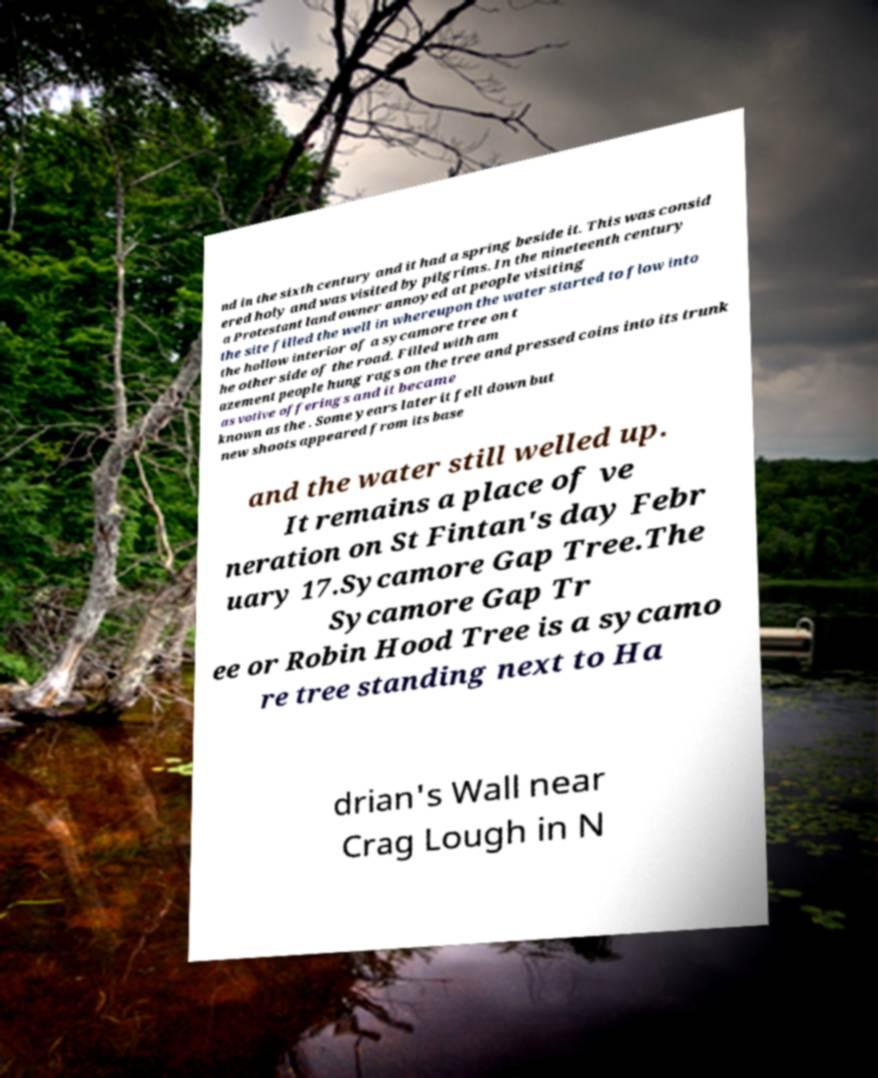Can you accurately transcribe the text from the provided image for me? nd in the sixth century and it had a spring beside it. This was consid ered holy and was visited by pilgrims. In the nineteenth century a Protestant land owner annoyed at people visiting the site filled the well in whereupon the water started to flow into the hollow interior of a sycamore tree on t he other side of the road. Filled with am azement people hung rags on the tree and pressed coins into its trunk as votive offerings and it became known as the . Some years later it fell down but new shoots appeared from its base and the water still welled up. It remains a place of ve neration on St Fintan's day Febr uary 17.Sycamore Gap Tree.The Sycamore Gap Tr ee or Robin Hood Tree is a sycamo re tree standing next to Ha drian's Wall near Crag Lough in N 